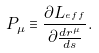<formula> <loc_0><loc_0><loc_500><loc_500>P _ { \mu } \equiv \frac { \partial L _ { ^ { e f f } } } { \partial \frac { d r ^ { \mu } } { d s } } .</formula> 